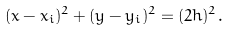<formula> <loc_0><loc_0><loc_500><loc_500>( x - x _ { i } ) ^ { 2 } + ( y - y _ { i } ) ^ { 2 } = ( 2 h ) ^ { 2 } .</formula> 